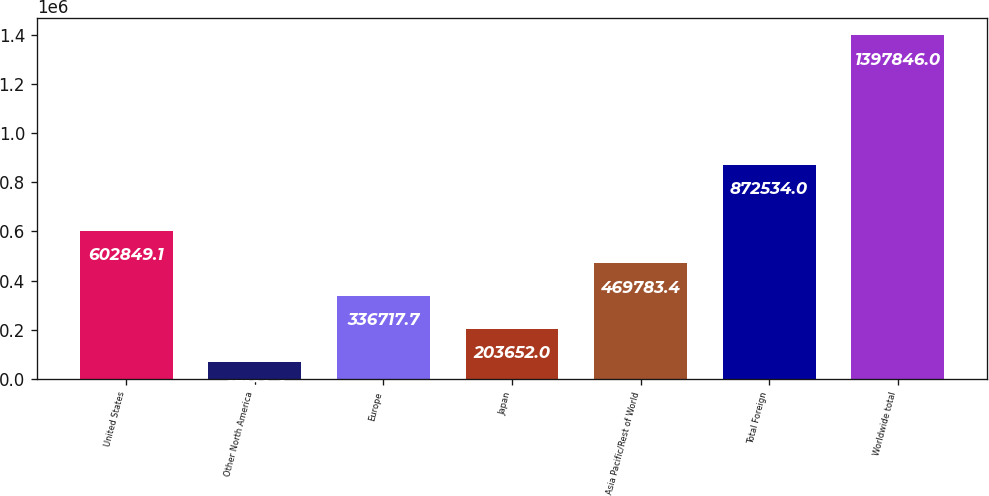Convert chart. <chart><loc_0><loc_0><loc_500><loc_500><bar_chart><fcel>United States<fcel>Other North America<fcel>Europe<fcel>Japan<fcel>Asia Pacific/Rest of World<fcel>Total Foreign<fcel>Worldwide total<nl><fcel>602849<fcel>67189<fcel>336718<fcel>203652<fcel>469783<fcel>872534<fcel>1.39785e+06<nl></chart> 